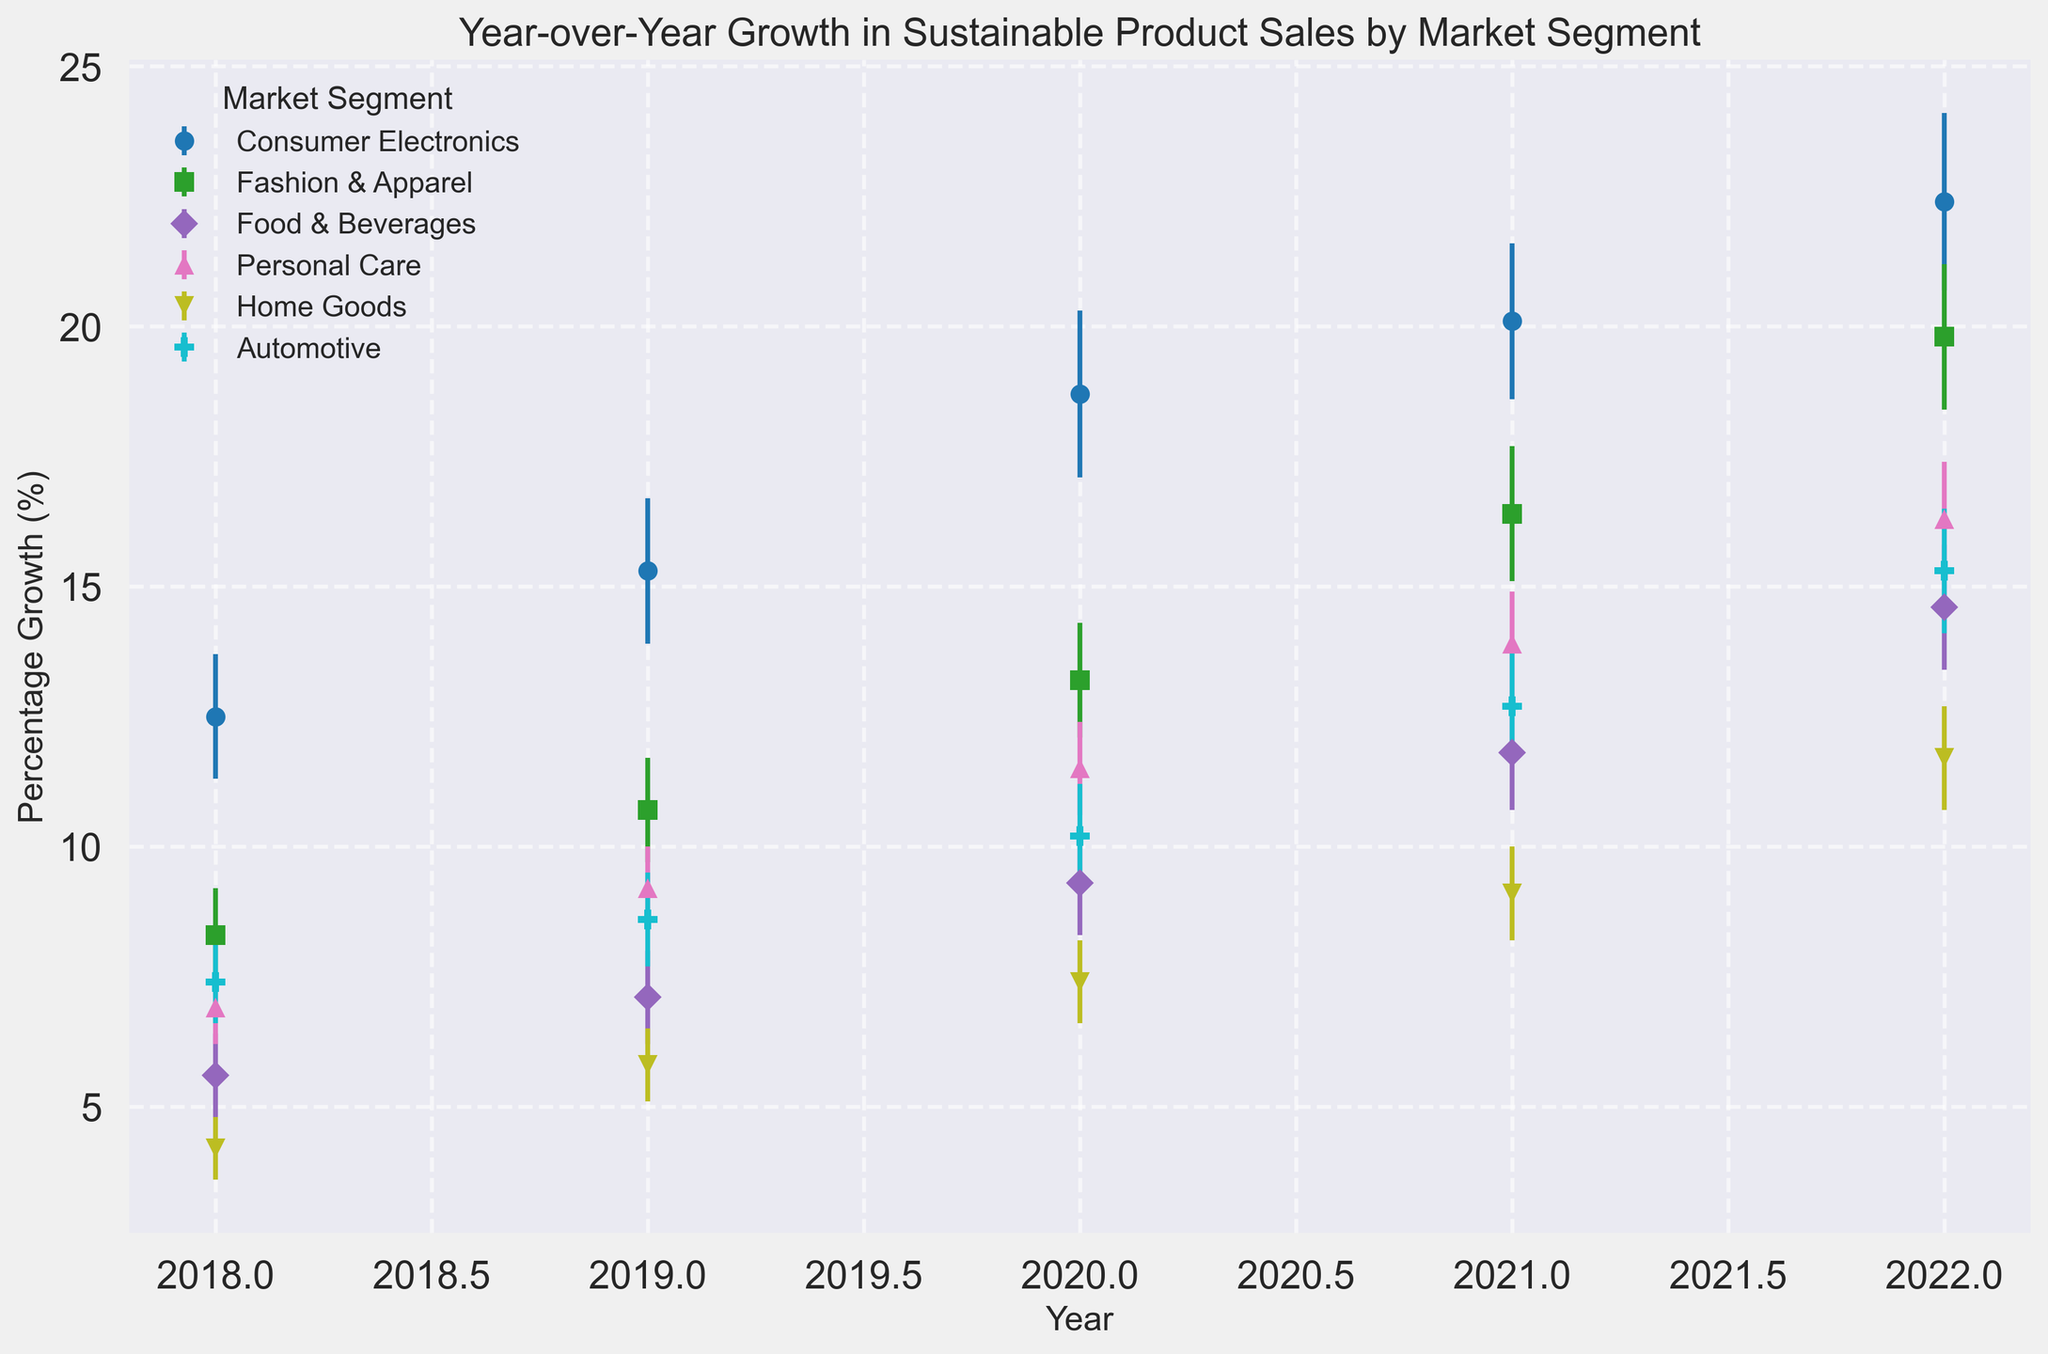What market segment exhibited the highest percentage growth in 2022? To find the highest percentage growth in 2022, look at the data points for each market segment's growth rate in that year and identify the largest value. The Consumer Electronics segment has the highest growth rate in 2022 with 22.4%.
Answer: Consumer Electronics How did the percentage growth in the Automotive segment compare between 2018 and 2022? To compare the percentage growth for the Automotive segment between 2018 and 2022, subtract the 2018 growth rate (7.4%) from the 2022 growth rate (15.3%) showing an increase of 15.3 - 7.4 = 7.9%.
Answer: Increased by 7.9% Which market segment had the second lowest growth rate in 2019? Look at the growth rates for all market segments in 2019 and identify the second smallest value. The second lowest growth rate in 2019 is 8.6% for the Automotive segment.
Answer: Automotive Which market segment saw the least change in percentage growth from 2018 to 2020? Calculate the difference in growth rates from 2018 to 2020 for each segment and identify the smallest change. The Home Goods segment had the smallest change from 4.2% in 2018 to 7.4% in 2020, which is an increase of 3.2%.
Answer: Home Goods What is the average percentage growth for the Fashion & Apparel segment from 2018 to 2022? Calculate the average by adding the growth rates for the Fashion & Apparel segment from each year (8.3% + 10.7% + 13.2% + 16.4% + 19.8%) and divide by the total number of years (5). The sum is 68.4%, and the average is 68.4 / 5 = 13.68%.
Answer: 13.68% Which two segments had the closest percentage growth rates in 2021? Compare the growth rates of all market segments in 2021 and identify the two rates that are closest to each other. The Fashion & Apparel segment (16.4%) and Personal Care segment (13.9%) have the closest growth rates (difference of 2.5%).
Answer: Fashion & Apparel and Personal Care What is the trend in percentage growth for the Food & Beverages segment from 2018 to 2022? Look at the growth rates for the Food & Beverages segment over the years 2018 to 2022 and observe the trend. The growth rates show a continuous increase from 5.6% to 14.6%.
Answer: Continuous increase In which year did the Fashion & Apparel segment have a growth rate closest to the average growth rate of all segments that year? Calculate the average growth rate for all segments in each year, then find the year in which Fashion & Apparel’s growth rate is closest to that average. For example, in 2019, the average growth rate is (15.3 + 10.7 + 7.1 + 9.2 + 5.8 + 8.6) / 6 = 9.45%. The Fashion & Apparel segment's growth rate of 10.7% is closest to the 2019 average.
Answer: 2019 